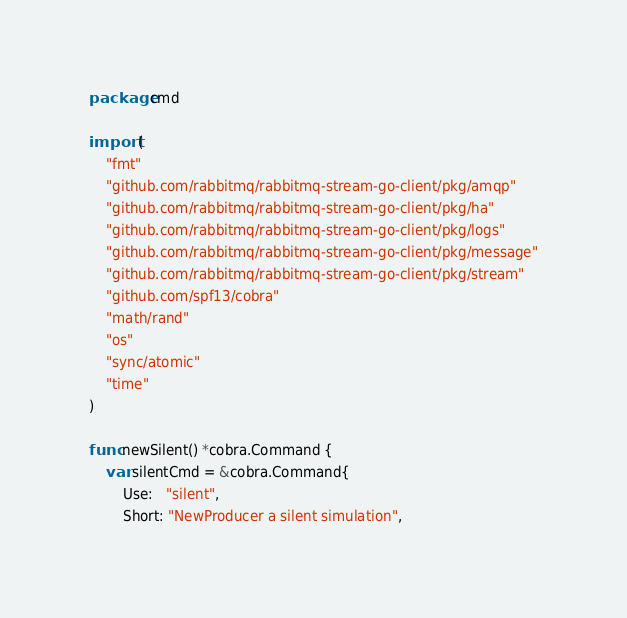Convert code to text. <code><loc_0><loc_0><loc_500><loc_500><_Go_>package cmd

import (
	"fmt"
	"github.com/rabbitmq/rabbitmq-stream-go-client/pkg/amqp"
	"github.com/rabbitmq/rabbitmq-stream-go-client/pkg/ha"
	"github.com/rabbitmq/rabbitmq-stream-go-client/pkg/logs"
	"github.com/rabbitmq/rabbitmq-stream-go-client/pkg/message"
	"github.com/rabbitmq/rabbitmq-stream-go-client/pkg/stream"
	"github.com/spf13/cobra"
	"math/rand"
	"os"
	"sync/atomic"
	"time"
)

func newSilent() *cobra.Command {
	var silentCmd = &cobra.Command{
		Use:   "silent",
		Short: "NewProducer a silent simulation",</code> 